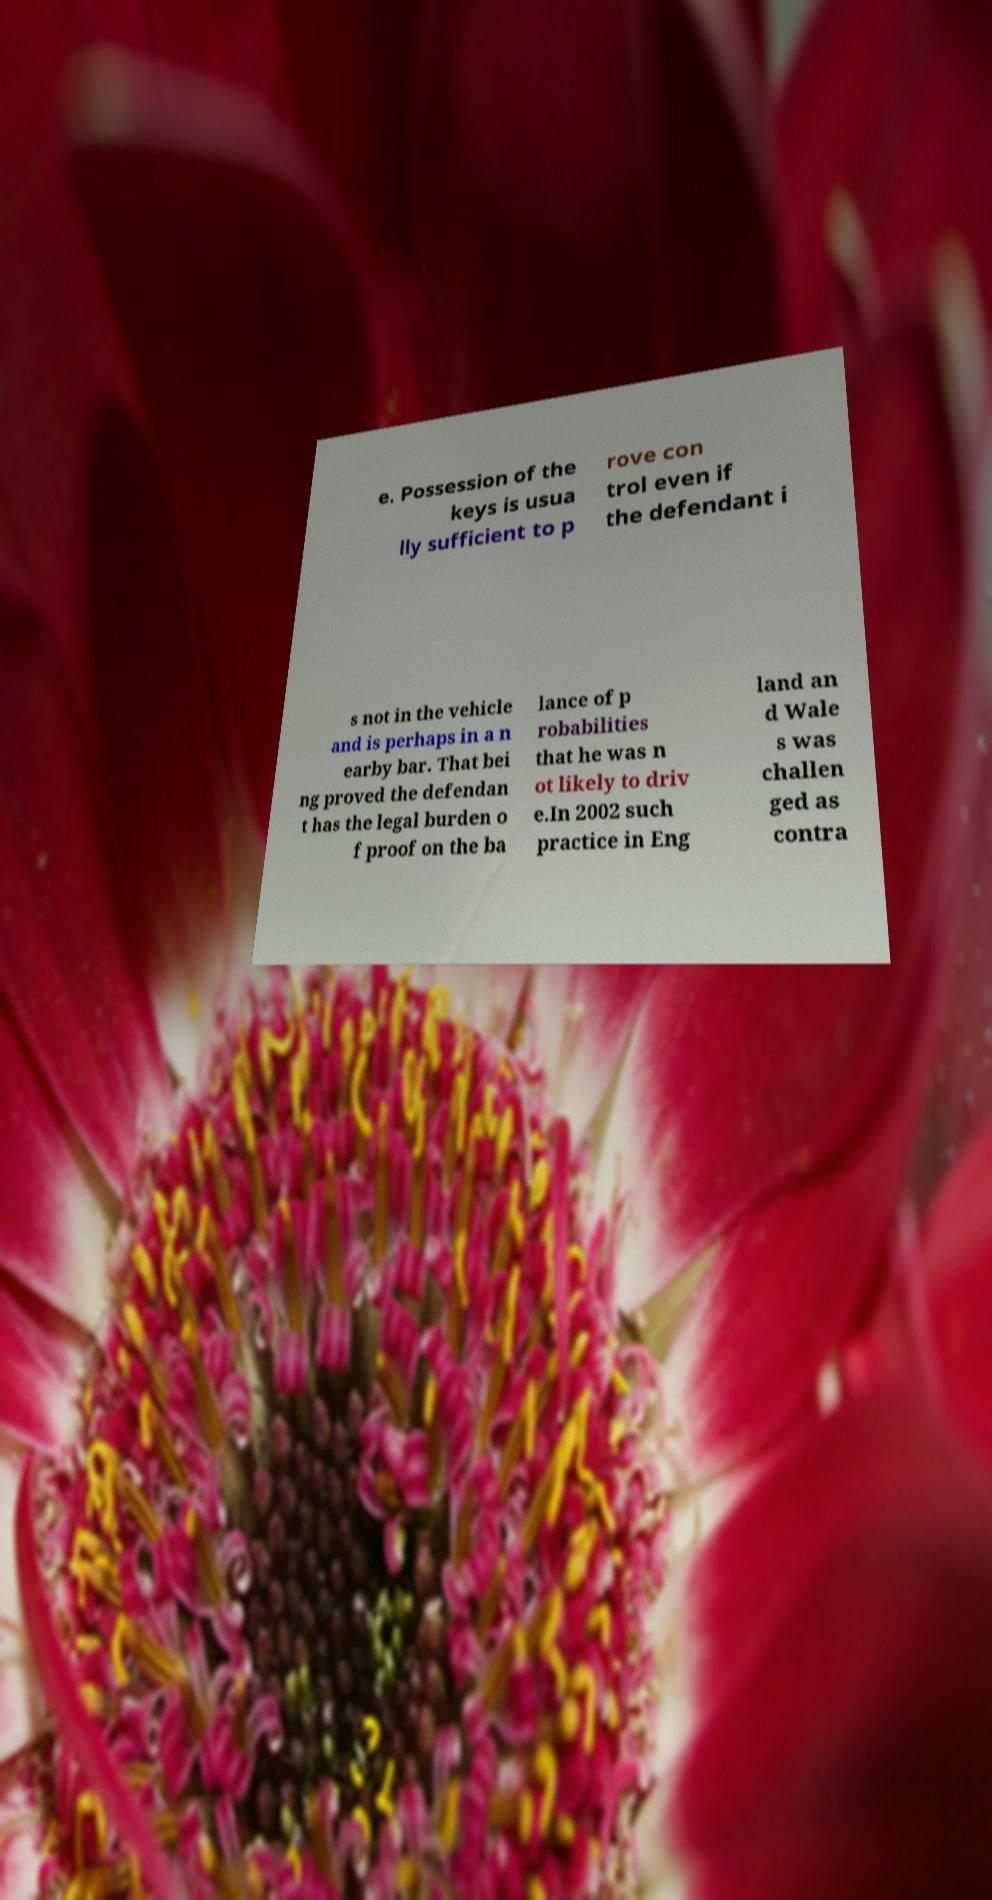Could you assist in decoding the text presented in this image and type it out clearly? e. Possession of the keys is usua lly sufficient to p rove con trol even if the defendant i s not in the vehicle and is perhaps in a n earby bar. That bei ng proved the defendan t has the legal burden o f proof on the ba lance of p robabilities that he was n ot likely to driv e.In 2002 such practice in Eng land an d Wale s was challen ged as contra 